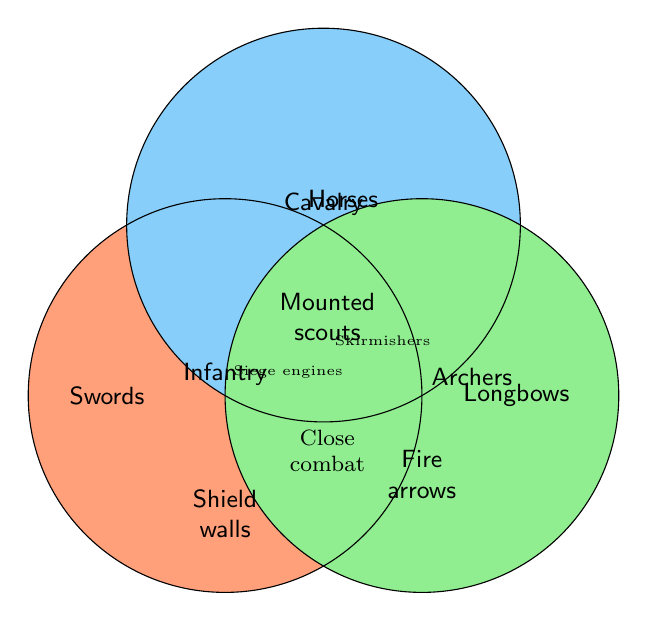Which warrior class is associated with "Swords"? The text "Swords" is found within the circle labeled "Infantry".
Answer: Infantry Which warrior class uses "Horses"? The term "Horses" is inside the circle labeled "Cavalry".
Answer: Cavalry Which term is common between Cavalry and Archers? "Skirmishers" is placed at the intersection between the Cavalry and Archers circles.
Answer: Skirmishers Which feature is unique to Archers? The text "Longbows" is within the Archers circle and not intersecting with any other circle.
Answer: Longbows What is shared between all three warrior classes? "Close Combat" is located at the intersection of all three circles.
Answer: Close Combat Name one element that is unique to Infantry and another that is unique to Cavalry. "Swords" is unique to Infantry, and "Mounted scouts" is unique to Cavalry.
Answer: Swords, Mounted scouts Do Cavalry and Infantry share any attributes? No text is located at the intersection of Cavalry and Infantry, so they do not share any attributes.
Answer: No Which circle's color is closest to green? The Archers circle is colored closest to green.
Answer: Archers Which features are associated with both Infantry and Archers, but not Cavalry? There are no features located at the intersection between Infantry and Archers, exclusive of Cavalry.
Answer: None 